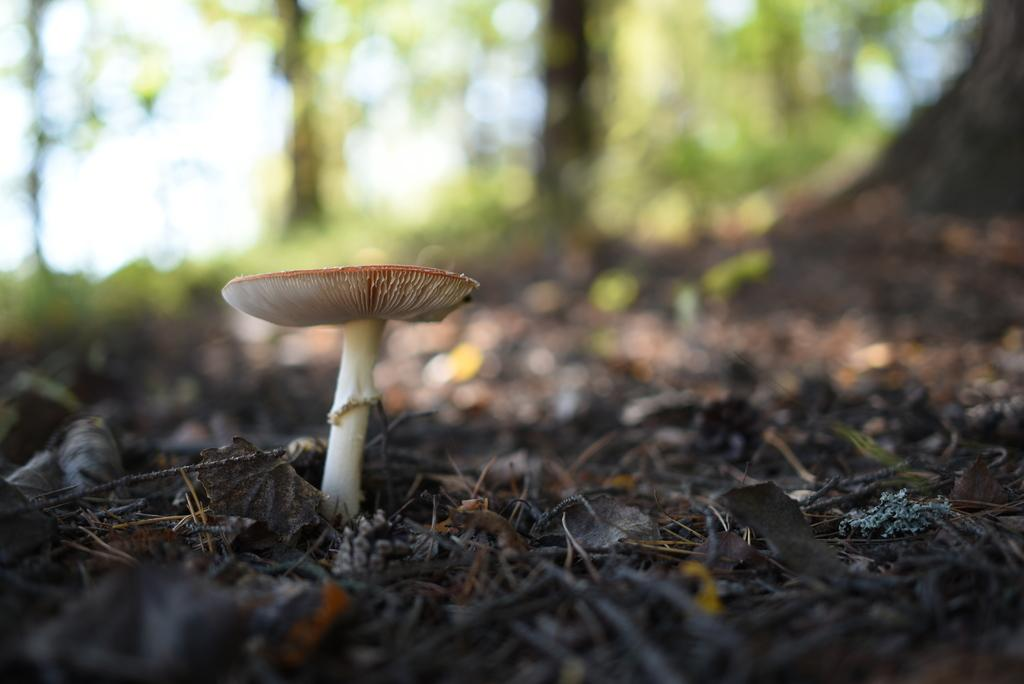What is the main subject of the image? There is a mushroom in the image. Can you describe the background of the image? The background of the image is blurry. What type of brush is being used to paint the mushroom in the image? There is no brush or painting activity present in the image; it features a mushroom with a blurry background. What desire does the mushroom have in the image? The mushroom is an inanimate object and does not have desires. 